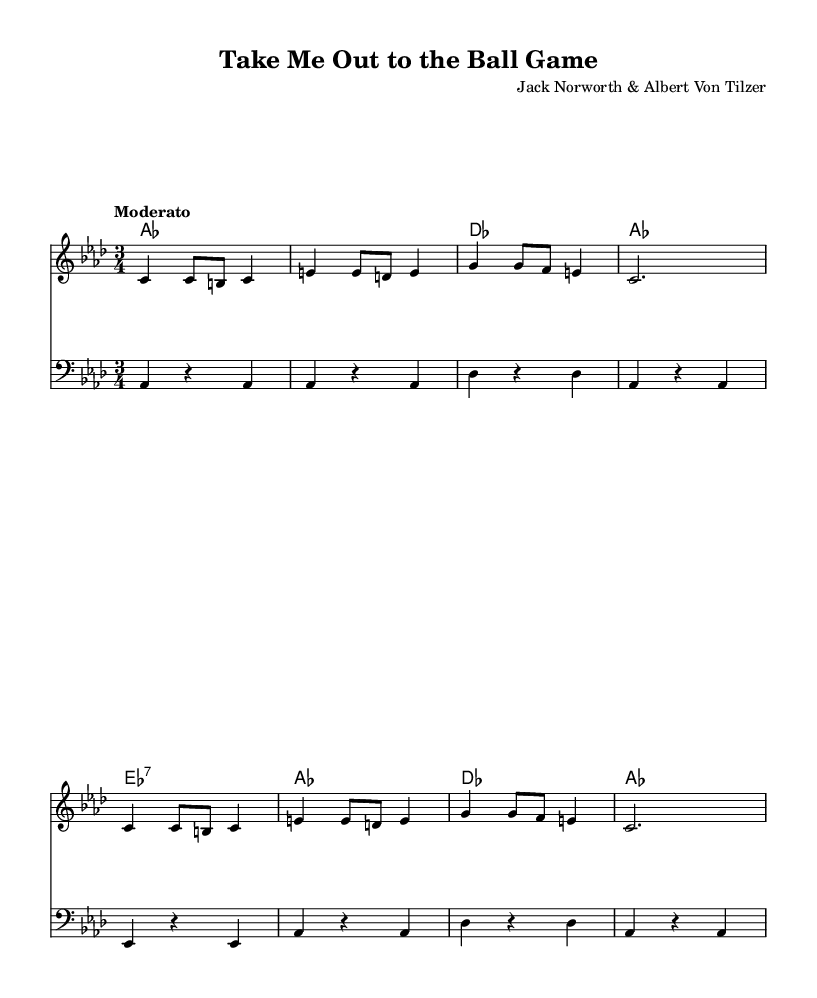What is the key signature of this music? The key signature is A flat major, which has four flats (B flat, E flat, A flat, and D flat).
Answer: A flat major What is the time signature of this music? The time signature is 3/4, which means there are three beats in each measure and a quarter note receives one beat.
Answer: 3/4 What is the tempo marking for this piece? The tempo marking is "Moderato," indicating a moderate pace for the performance.
Answer: Moderato How many measures are present in the melody section? Counting the measures in the melody, there are eight distinct measures, determined by the vertical lines indicating bar divisions.
Answer: 8 What is the harmonic function of the chord marked as E flat 7? The E flat 7 chord functions as a dominant seventh chord, suggesting a resolution back to the tonic A flat major.
Answer: Dominant seventh What is the rhythmic pattern used in the melody's first measure? The rhythmic pattern consists of two quarter notes followed by one eighth note, typical of a waltz feel in 3/4 time.
Answer: Two quarter notes and one eighth note What is the last note of the bass staff? The last note displayed in the bass staff is an A flat, which serves as the tonic note of the piece.
Answer: A flat 